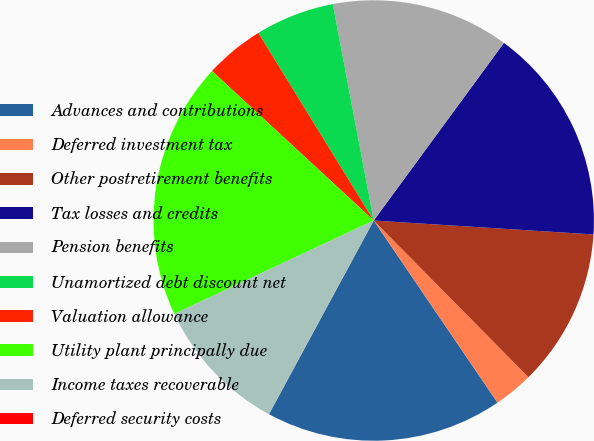<chart> <loc_0><loc_0><loc_500><loc_500><pie_chart><fcel>Advances and contributions<fcel>Deferred investment tax<fcel>Other postretirement benefits<fcel>Tax losses and credits<fcel>Pension benefits<fcel>Unamortized debt discount net<fcel>Valuation allowance<fcel>Utility plant principally due<fcel>Income taxes recoverable<fcel>Deferred security costs<nl><fcel>17.39%<fcel>2.9%<fcel>11.59%<fcel>15.94%<fcel>13.04%<fcel>5.8%<fcel>4.35%<fcel>18.84%<fcel>10.14%<fcel>0.0%<nl></chart> 